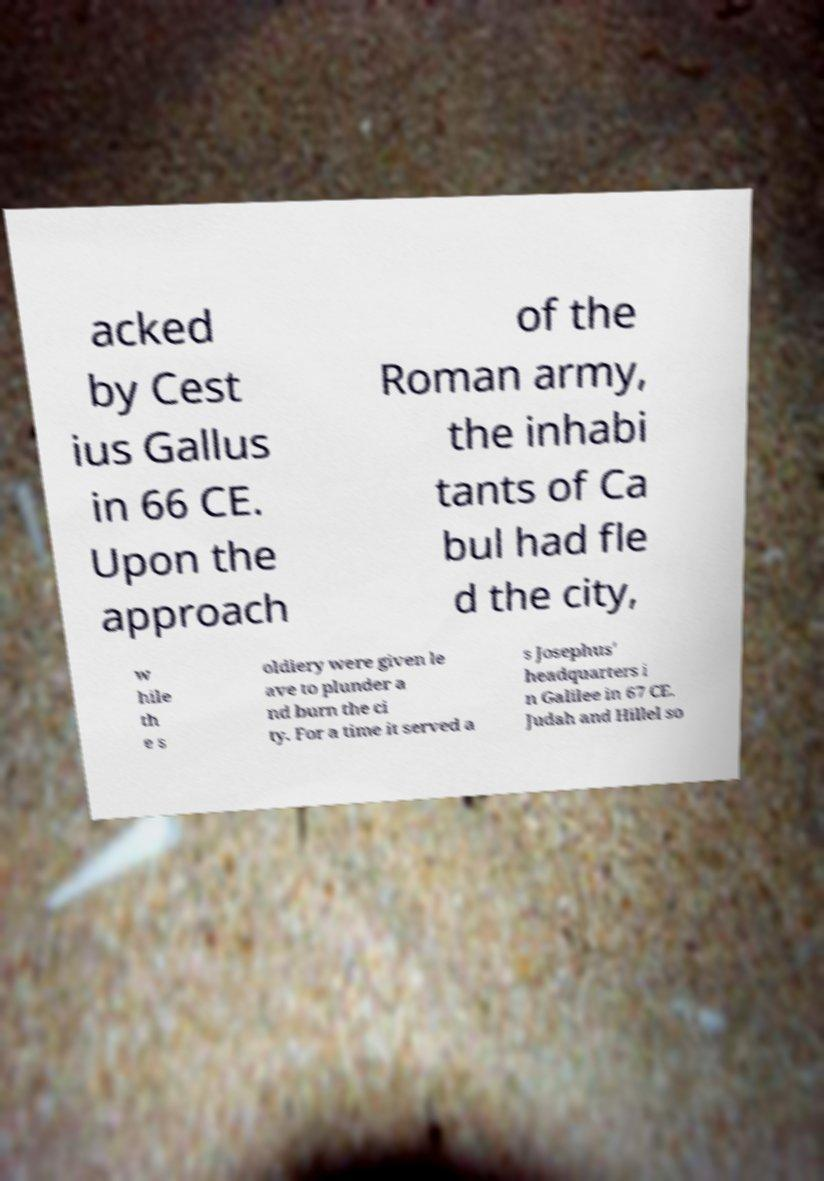Please read and relay the text visible in this image. What does it say? acked by Cest ius Gallus in 66 CE. Upon the approach of the Roman army, the inhabi tants of Ca bul had fle d the city, w hile th e s oldiery were given le ave to plunder a nd burn the ci ty. For a time it served a s Josephus' headquarters i n Galilee in 67 CE. Judah and Hillel so 